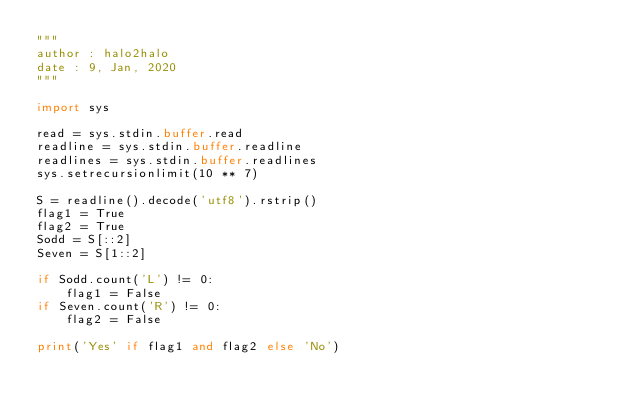<code> <loc_0><loc_0><loc_500><loc_500><_Python_>"""
author : halo2halo
date : 9, Jan, 2020
"""

import sys

read = sys.stdin.buffer.read
readline = sys.stdin.buffer.readline
readlines = sys.stdin.buffer.readlines
sys.setrecursionlimit(10 ** 7)

S = readline().decode('utf8').rstrip()
flag1 = True
flag2 = True
Sodd = S[::2]
Seven = S[1::2]

if Sodd.count('L') != 0:
    flag1 = False
if Seven.count('R') != 0:
    flag2 = False

print('Yes' if flag1 and flag2 else 'No')
</code> 